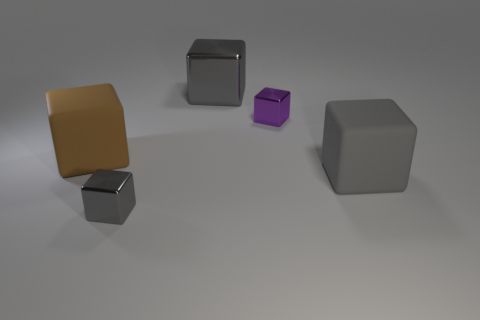Subtract all green cylinders. How many gray blocks are left? 3 Subtract 2 cubes. How many cubes are left? 3 Subtract all purple cubes. How many cubes are left? 4 Subtract all gray rubber blocks. How many blocks are left? 4 Subtract all yellow cubes. Subtract all red spheres. How many cubes are left? 5 Add 2 tiny yellow cylinders. How many objects exist? 7 Add 4 small brown matte things. How many small brown matte things exist? 4 Subtract 0 gray spheres. How many objects are left? 5 Subtract all tiny gray metallic things. Subtract all gray metallic objects. How many objects are left? 2 Add 3 gray matte things. How many gray matte things are left? 4 